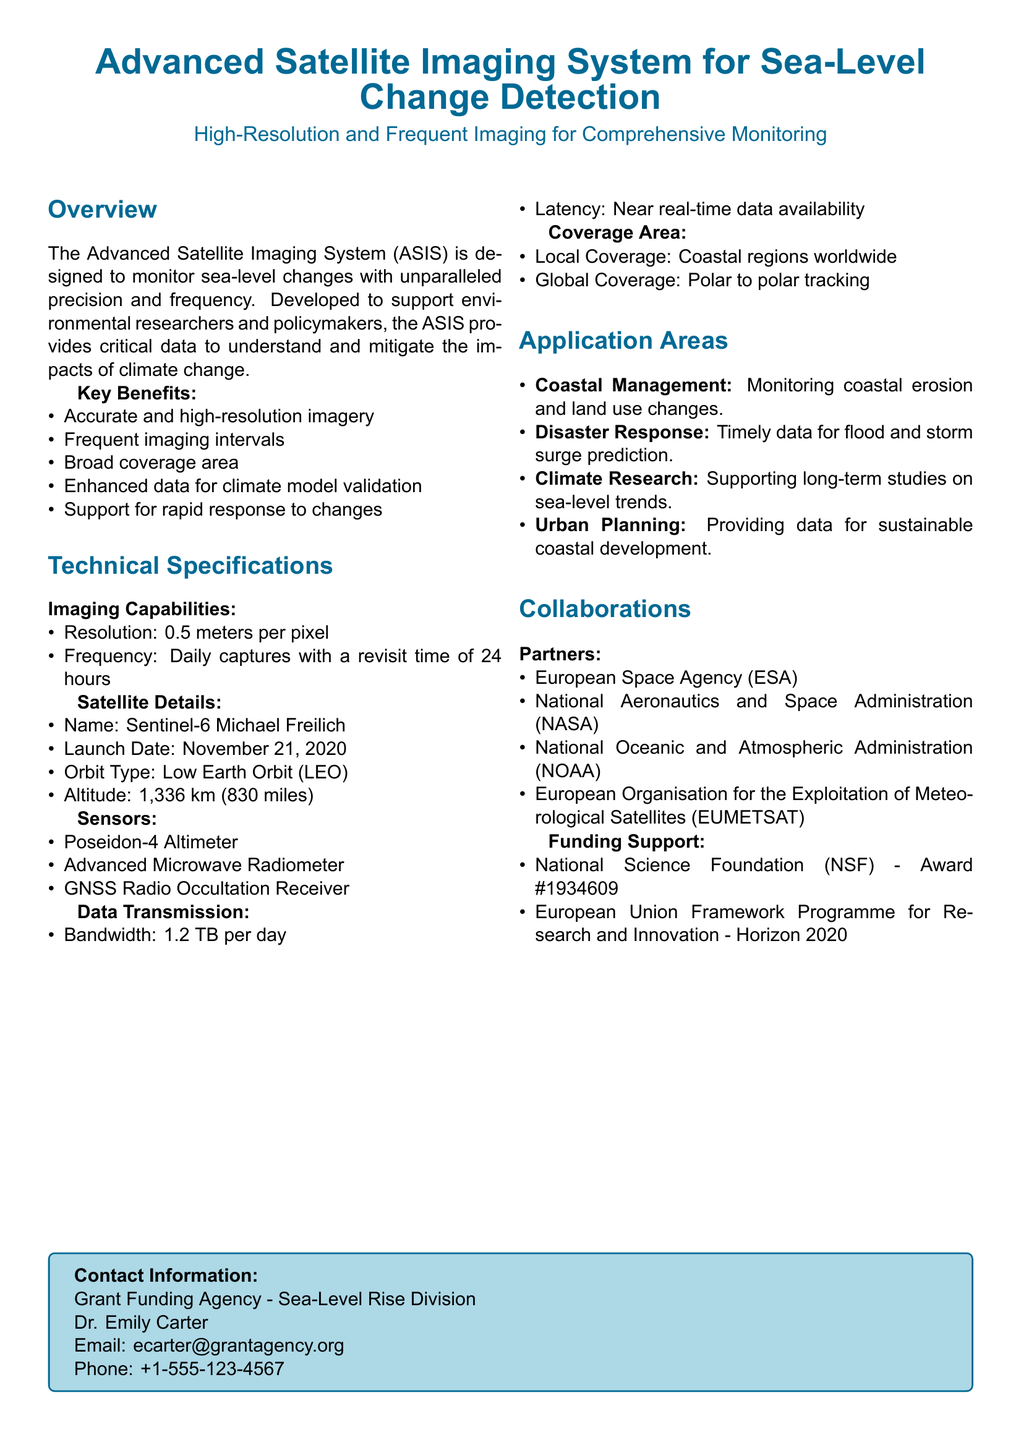what is the resolution of the imaging system? The resolution is stated in the Imaging Capabilities section, which specifies "0.5 meters per pixel."
Answer: 0.5 meters per pixel what is the frequency of imaging captures? The frequency is also detailed in the Imaging Capabilities section, which highlights "Daily captures with a revisit time of 24 hours."
Answer: Daily captures who is the satellite named after? The satellite name is presented in the Satellite Details section as "Sentinel-6 Michael Freilich."
Answer: Michael Freilich what is the bandwidth for data transmission? The bandwidth is provided in the Data Transmission section, stating "1.2 TB per day."
Answer: 1.2 TB per day what are the application areas mentioned? The document lists multiple areas under the Application Areas section, one of which is "Coastal Management."
Answer: Coastal Management which organization launched the satellite? The satellite's launch date is mentioned alongside the organization in the Satellite Details section, which is the "National Aeronautics and Space Administration (NASA)."
Answer: NASA how many partners are listed for collaborations? The partners are detailed in the Collaborations section, where a total of four organizations are enumerated.
Answer: Four what is the orbit type of the satellite? The orbit type is specified in the Satellite Details section as "Low Earth Orbit (LEO)."
Answer: Low Earth Orbit (LEO) what kind of sensor is used in the imaging system? The Sensors section lists the first sensor as "Poseidon-4 Altimeter."
Answer: Poseidon-4 Altimeter 